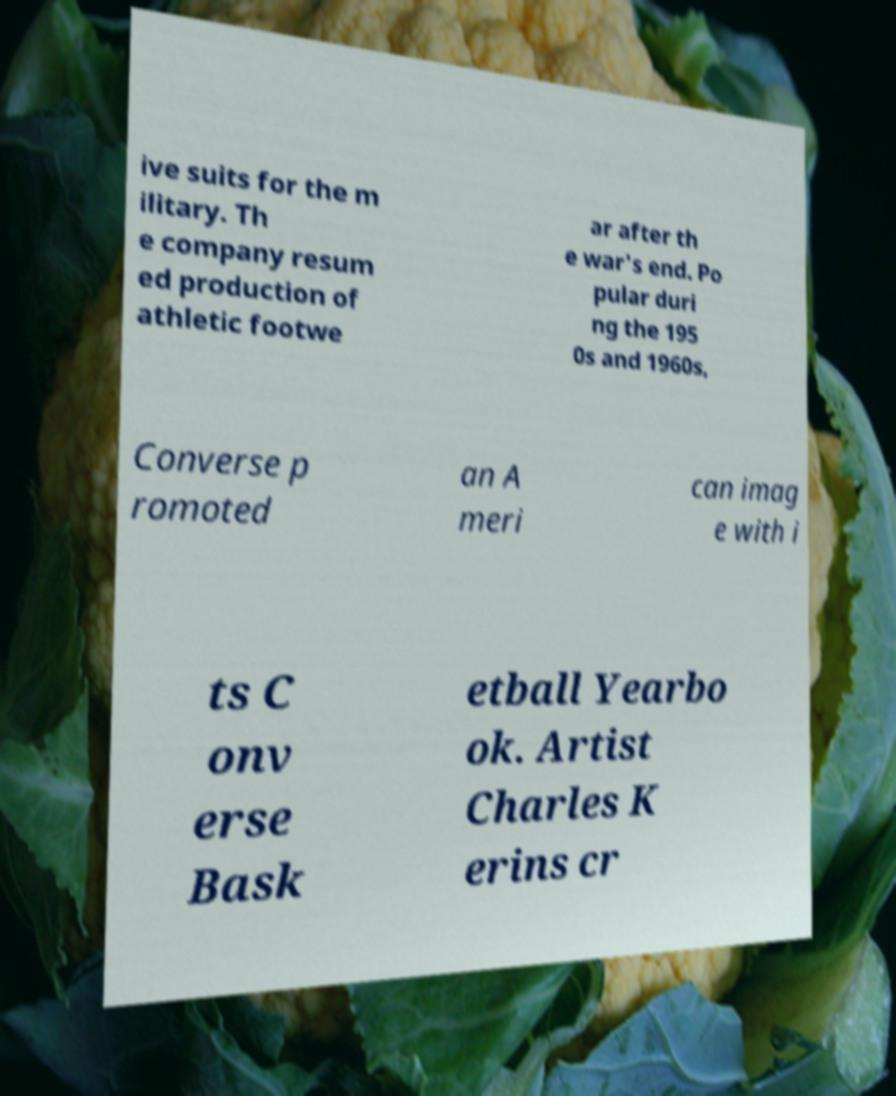Can you accurately transcribe the text from the provided image for me? ive suits for the m ilitary. Th e company resum ed production of athletic footwe ar after th e war's end. Po pular duri ng the 195 0s and 1960s, Converse p romoted an A meri can imag e with i ts C onv erse Bask etball Yearbo ok. Artist Charles K erins cr 